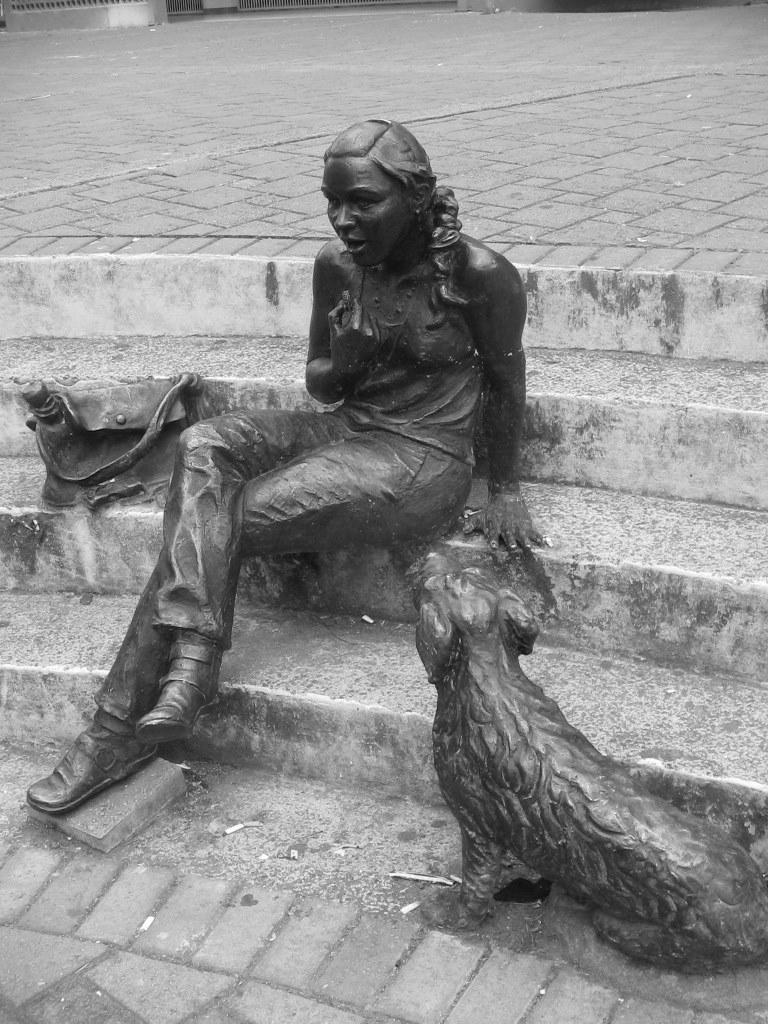What type of objects are present in the image? There are statues in the image. Can you describe the statues? The statues include a woman, a bag, and an animal. What can be seen in the background of the image? There is ground visible in the background of the image, and there are steps as well. Is there a river flowing near the statues in the image? There is no river visible in the image; only the ground and steps can be seen in the background. 